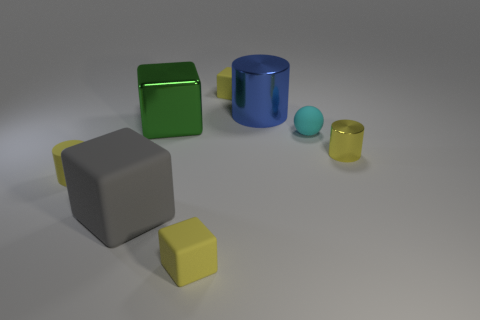Subtract all yellow shiny cylinders. How many cylinders are left? 2 Add 1 small brown balls. How many objects exist? 9 Subtract all yellow cylinders. How many cylinders are left? 1 Subtract all cylinders. How many objects are left? 5 Add 6 large rubber cubes. How many large rubber cubes are left? 7 Add 7 yellow rubber cylinders. How many yellow rubber cylinders exist? 8 Subtract 0 gray cylinders. How many objects are left? 8 Subtract 1 cylinders. How many cylinders are left? 2 Subtract all yellow cylinders. Subtract all purple balls. How many cylinders are left? 1 Subtract all yellow cubes. How many yellow cylinders are left? 2 